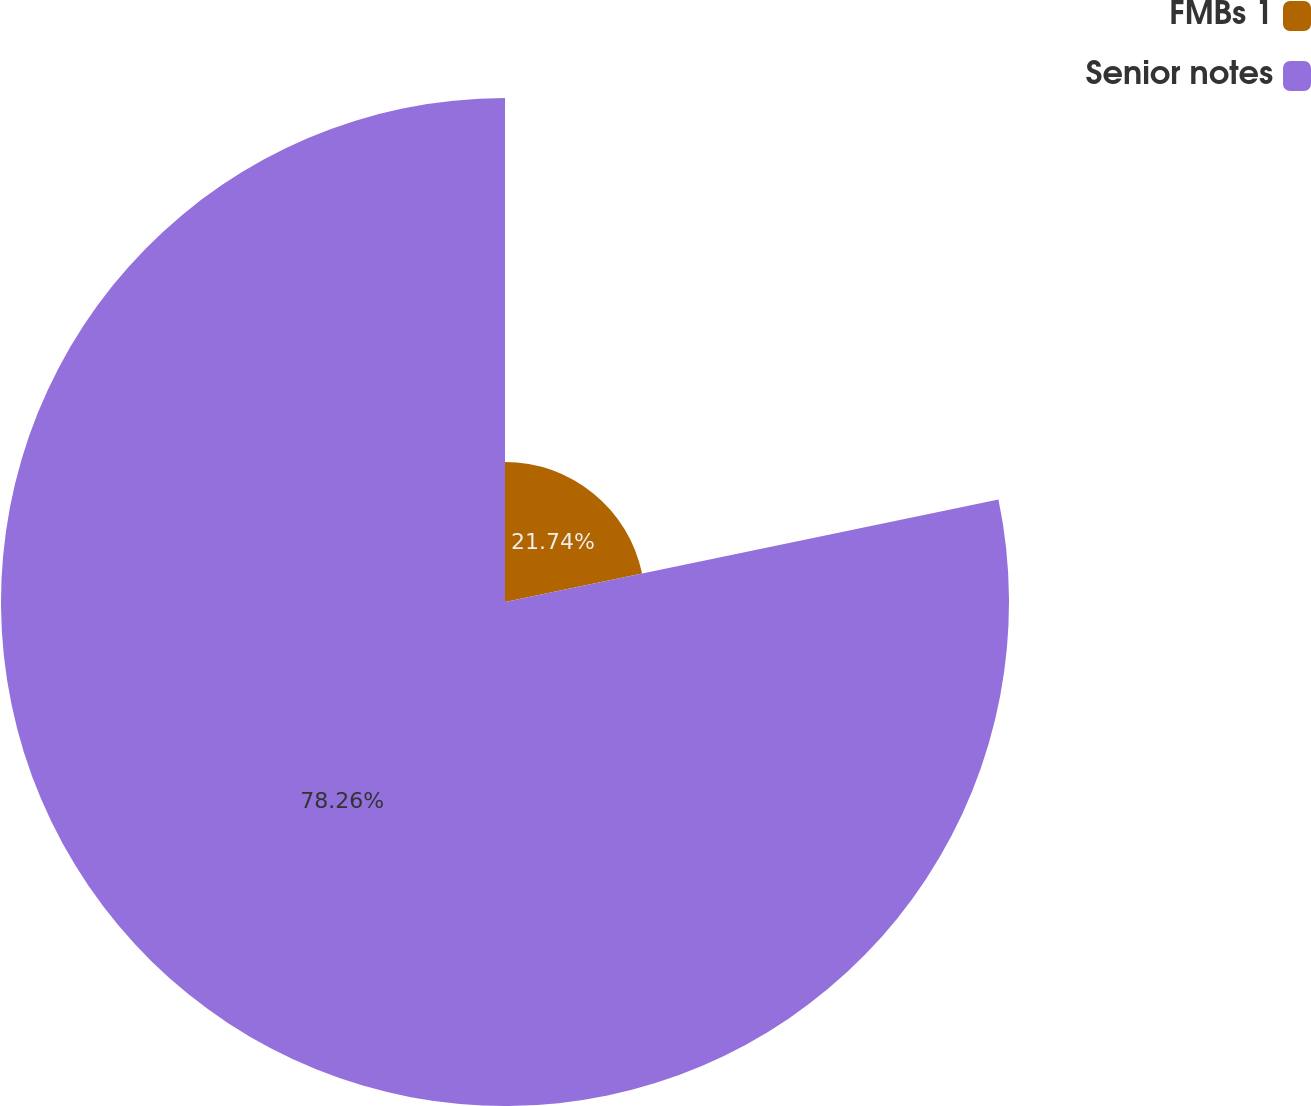Convert chart. <chart><loc_0><loc_0><loc_500><loc_500><pie_chart><fcel>FMBs 1<fcel>Senior notes<nl><fcel>21.74%<fcel>78.26%<nl></chart> 